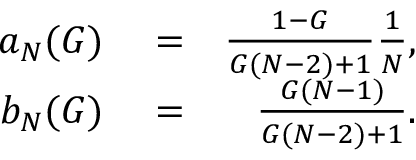Convert formula to latex. <formula><loc_0><loc_0><loc_500><loc_500>\begin{array} { r l r } { a _ { N } ( G ) } & = } & { \frac { 1 - G } { G ( N - 2 ) + 1 } \frac { 1 } { N } , } \\ { b _ { N } ( G ) } & = } & { \frac { G ( N - 1 ) } { G ( N - 2 ) + 1 } . } \end{array}</formula> 